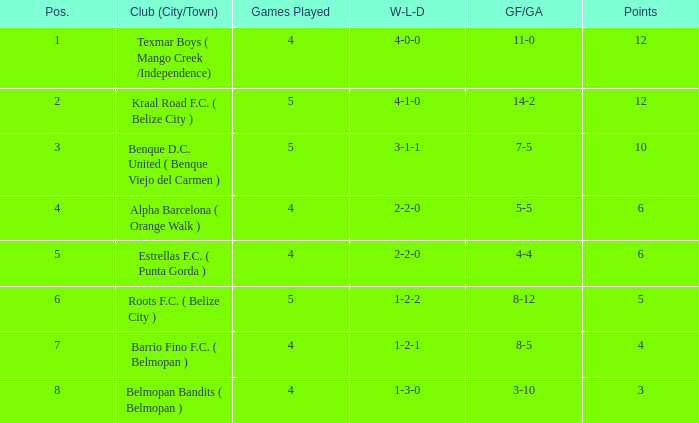What is the minimum points with goals for/against being 8-5 4.0. 